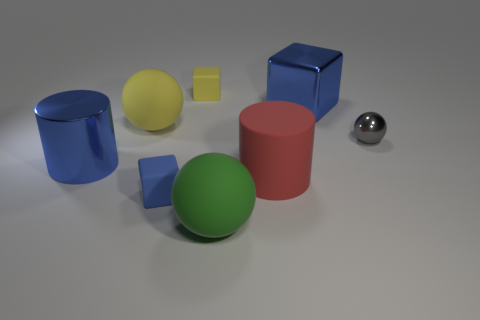What is the material of the blue thing that is left of the rubber cube that is in front of the large cylinder that is to the left of the large red matte thing?
Make the answer very short. Metal. What is the shape of the yellow matte thing that is the same size as the red rubber cylinder?
Your answer should be compact. Sphere. How many things are either cylinders or rubber spheres that are to the left of the small yellow thing?
Your answer should be compact. 3. Is the yellow block that is left of the small sphere made of the same material as the large cylinder to the left of the big red cylinder?
Your answer should be very brief. No. What is the shape of the matte thing that is the same color as the big metallic cylinder?
Your answer should be compact. Cube. How many red objects are either blocks or shiny cubes?
Give a very brief answer. 0. What is the size of the yellow cube?
Ensure brevity in your answer.  Small. Are there more big blue things that are in front of the big blue shiny cube than gray objects?
Make the answer very short. No. How many big red cylinders are in front of the green thing?
Provide a succinct answer. 0. Is there a blue matte object that has the same size as the gray sphere?
Your response must be concise. Yes. 